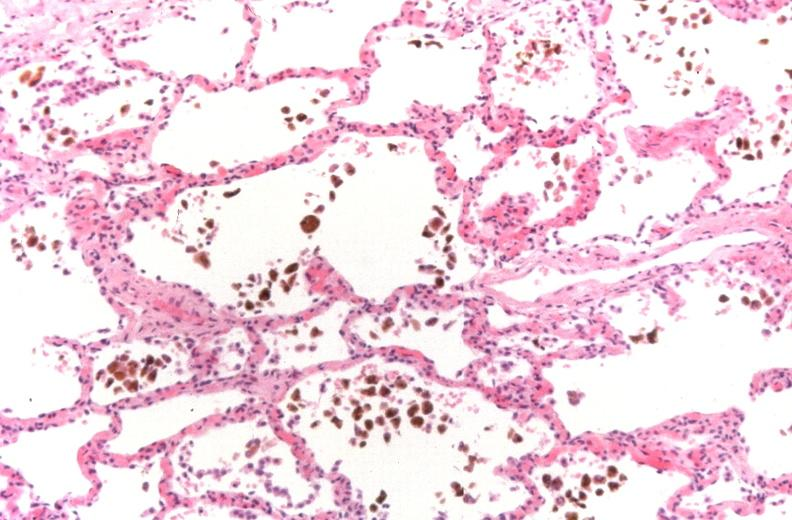where is this?
Answer the question using a single word or phrase. Lung 